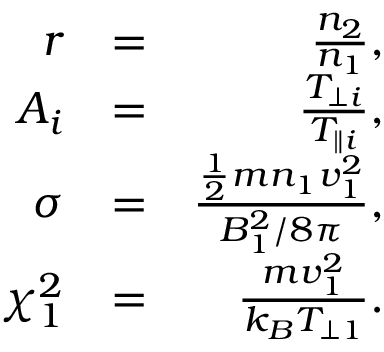<formula> <loc_0><loc_0><loc_500><loc_500>\begin{array} { r l r } { r } & { = } & { \frac { n _ { 2 } } { n _ { 1 } } , } \\ { A _ { i } } & { = } & { \frac { T _ { \perp i } } { T _ { \| i } } , } \\ { \sigma } & { = } & { \frac { \frac { 1 } { 2 } m n _ { 1 } v _ { 1 } ^ { 2 } } { B _ { 1 } ^ { 2 } / 8 \pi } , } \\ { \chi _ { 1 } ^ { 2 } } & { = } & { \frac { m v _ { 1 } ^ { 2 } } { k _ { B } T _ { \perp 1 } } . } \end{array}</formula> 